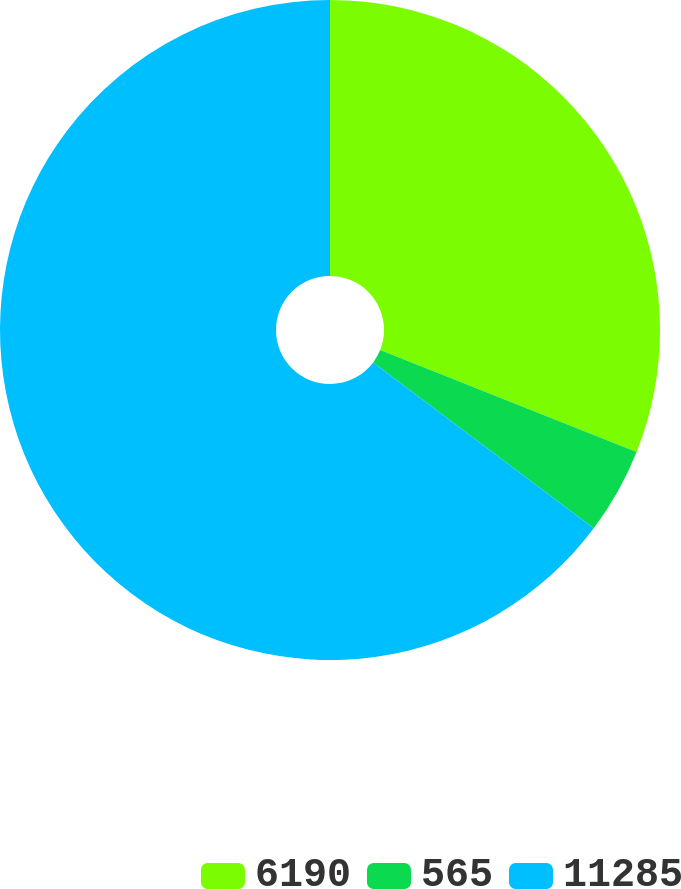Convert chart. <chart><loc_0><loc_0><loc_500><loc_500><pie_chart><fcel>6190<fcel>565<fcel>11285<nl><fcel>31.03%<fcel>4.23%<fcel>64.74%<nl></chart> 